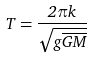<formula> <loc_0><loc_0><loc_500><loc_500>T = \frac { 2 \pi k } { \sqrt { g \overline { G M } } }</formula> 